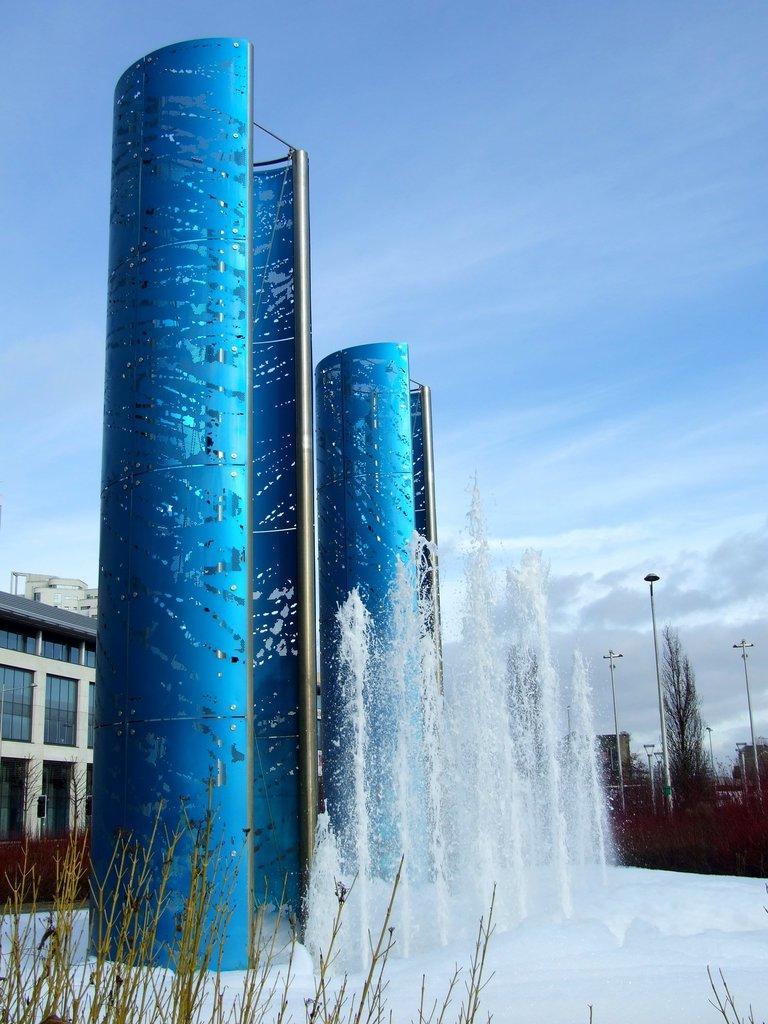Please provide a concise description of this image. In the image I can see a building and to the side there is a water fountain and around there are some poles, trees and plants. 